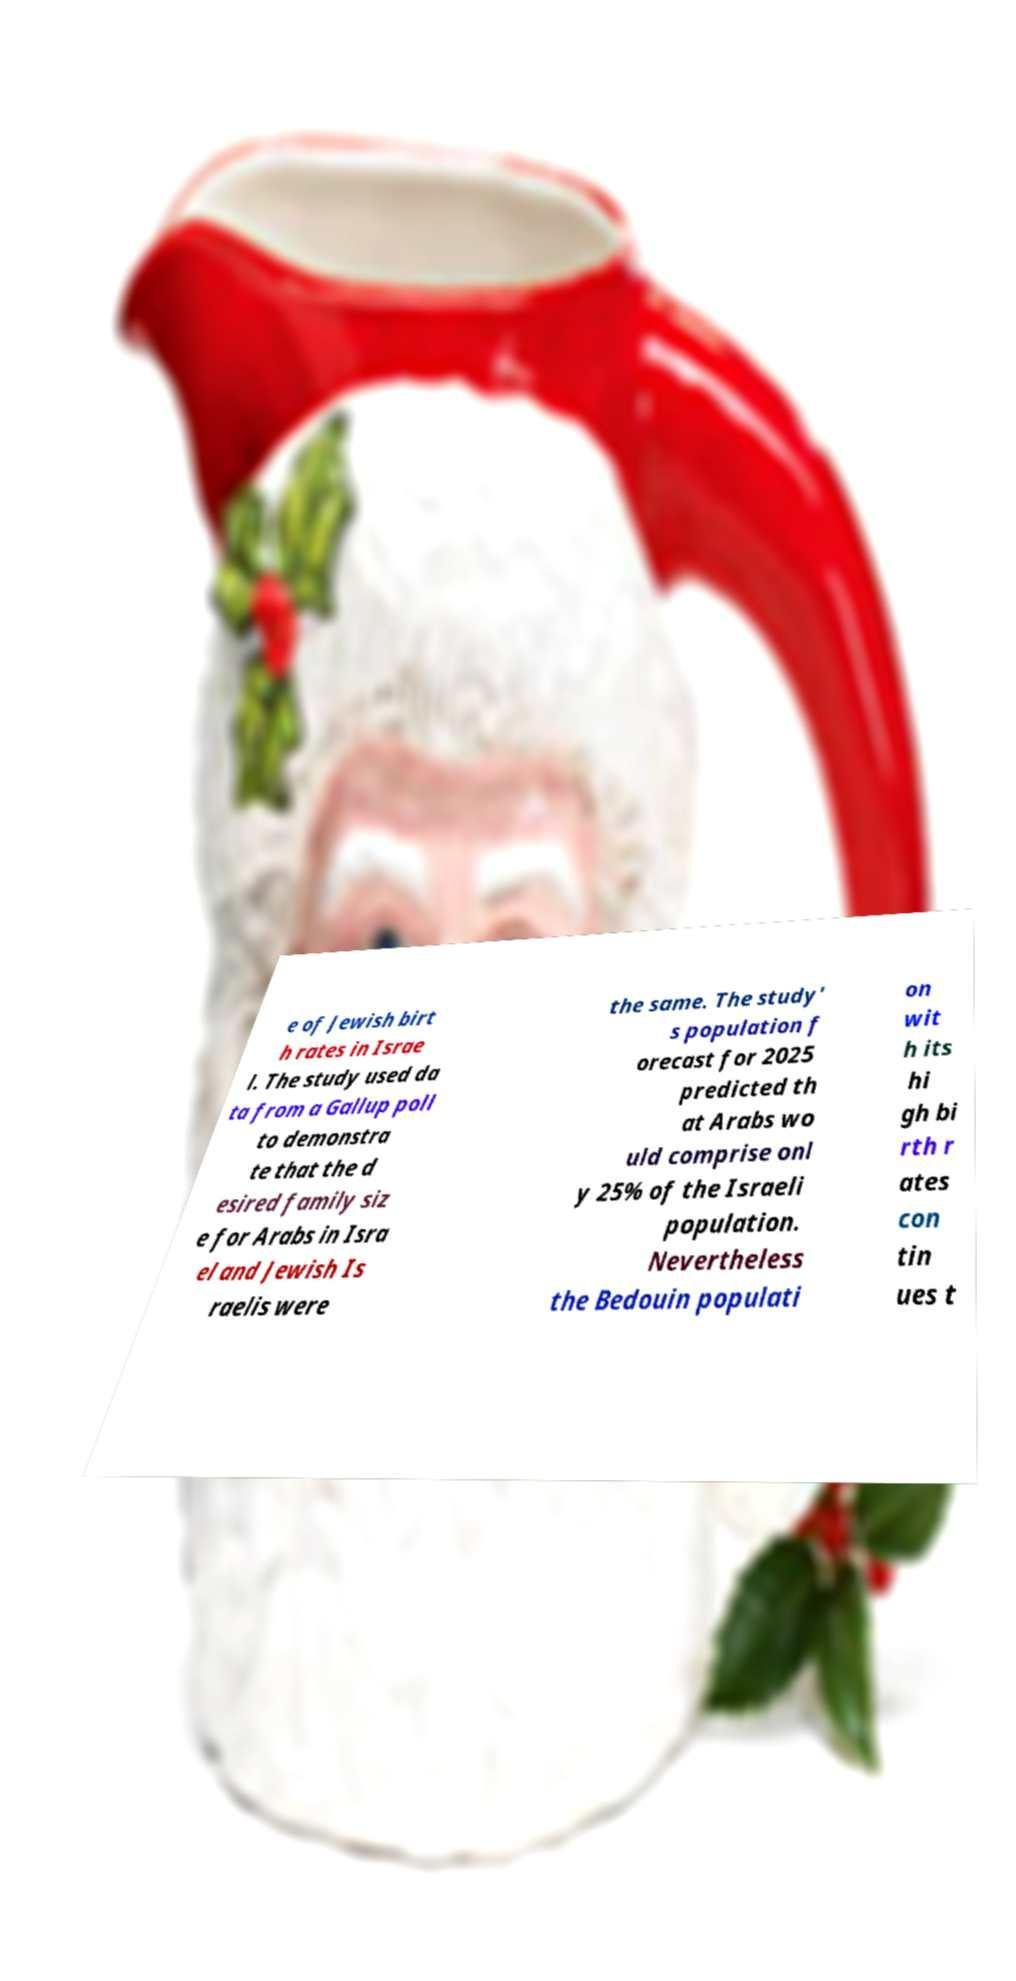Can you accurately transcribe the text from the provided image for me? e of Jewish birt h rates in Israe l. The study used da ta from a Gallup poll to demonstra te that the d esired family siz e for Arabs in Isra el and Jewish Is raelis were the same. The study' s population f orecast for 2025 predicted th at Arabs wo uld comprise onl y 25% of the Israeli population. Nevertheless the Bedouin populati on wit h its hi gh bi rth r ates con tin ues t 